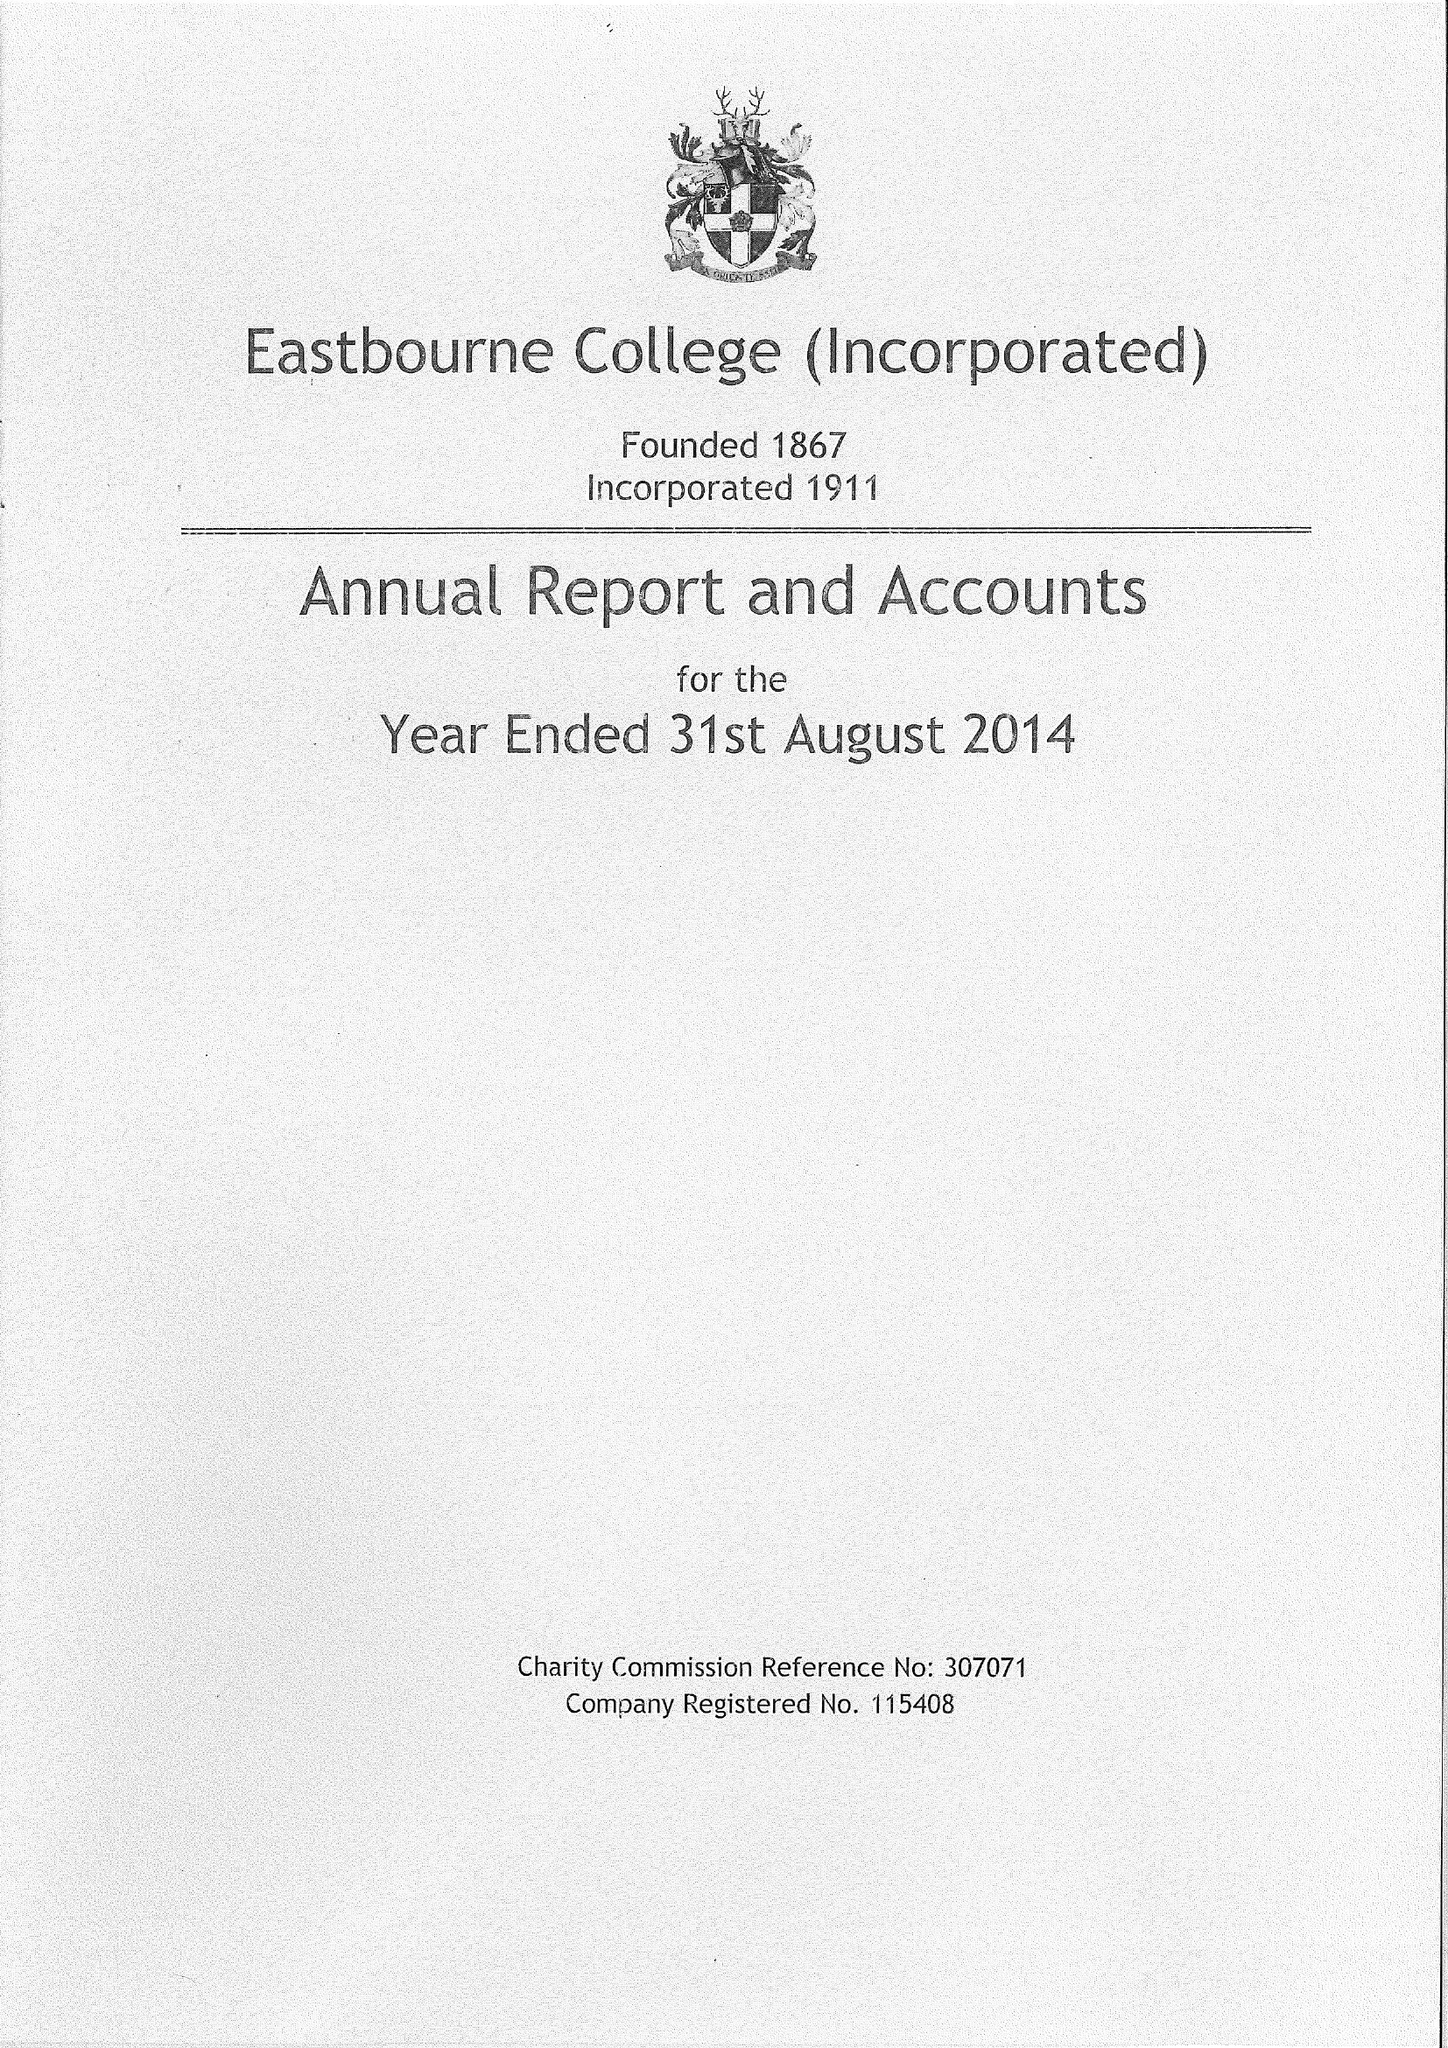What is the value for the address__street_line?
Answer the question using a single word or phrase. OLD WISH ROAD 